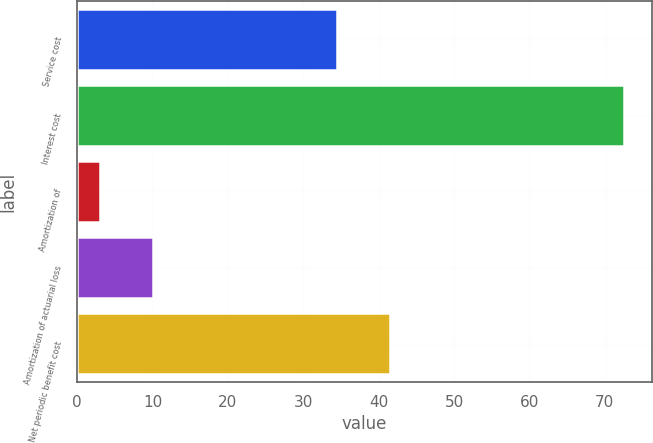Convert chart to OTSL. <chart><loc_0><loc_0><loc_500><loc_500><bar_chart><fcel>Service cost<fcel>Interest cost<fcel>Amortization of<fcel>Amortization of actuarial loss<fcel>Net periodic benefit cost<nl><fcel>34.5<fcel>72.6<fcel>3.1<fcel>10.05<fcel>41.45<nl></chart> 